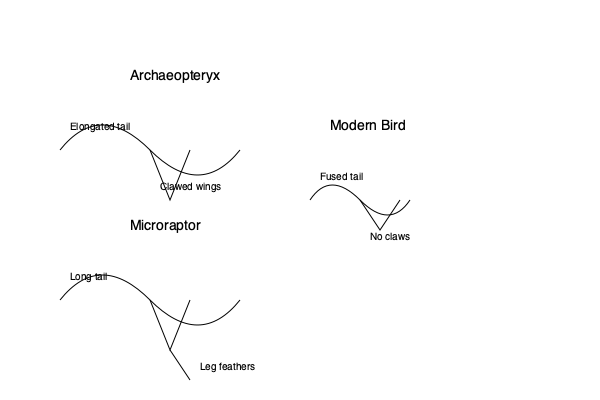Examine the skeletal diagrams of Archaeopteryx, Microraptor, and a modern bird. Which unique anatomical feature of Microraptor sets it apart from both Archaeopteryx and modern birds, potentially contributing to its distinctive flight or gliding capabilities? To answer this question, let's analyze the skeletal structures of each species step-by-step:

1. Archaeopteryx:
   - Elongated tail
   - Clawed wings
   - Overall dinosaur-like skeletal structure

2. Microraptor:
   - Long tail (similar to Archaeopteryx)
   - Clawed wings (similar to Archaeopteryx)
   - Distinct leg feathers

3. Modern bird:
   - Fused tail (pygostyle)
   - No claws on wings
   - More compact skeletal structure

The key difference that sets Microraptor apart is the presence of leg feathers. This feature is not observed in the Archaeopteryx or modern bird skeletons.

The leg feathers of Microraptor are a unique adaptation that likely played a role in its flight or gliding capabilities. This feature suggests that Microraptor may have used all four limbs in some form of aerial locomotion, possibly as a biplane-like configuration or for additional stability during gliding.

This anatomical feature is significant because:
a) It's not present in earlier dino-bird species like Archaeopteryx
b) It's not retained in the lineage leading to modern birds
c) It represents a novel evolutionary experiment in flight adaptation

Thus, the leg feathers of Microraptor represent a unique anatomical feature that distinguishes it from both its predecessors and its descendants in the evolutionary timeline of dino-birds to modern birds.
Answer: Leg feathers 